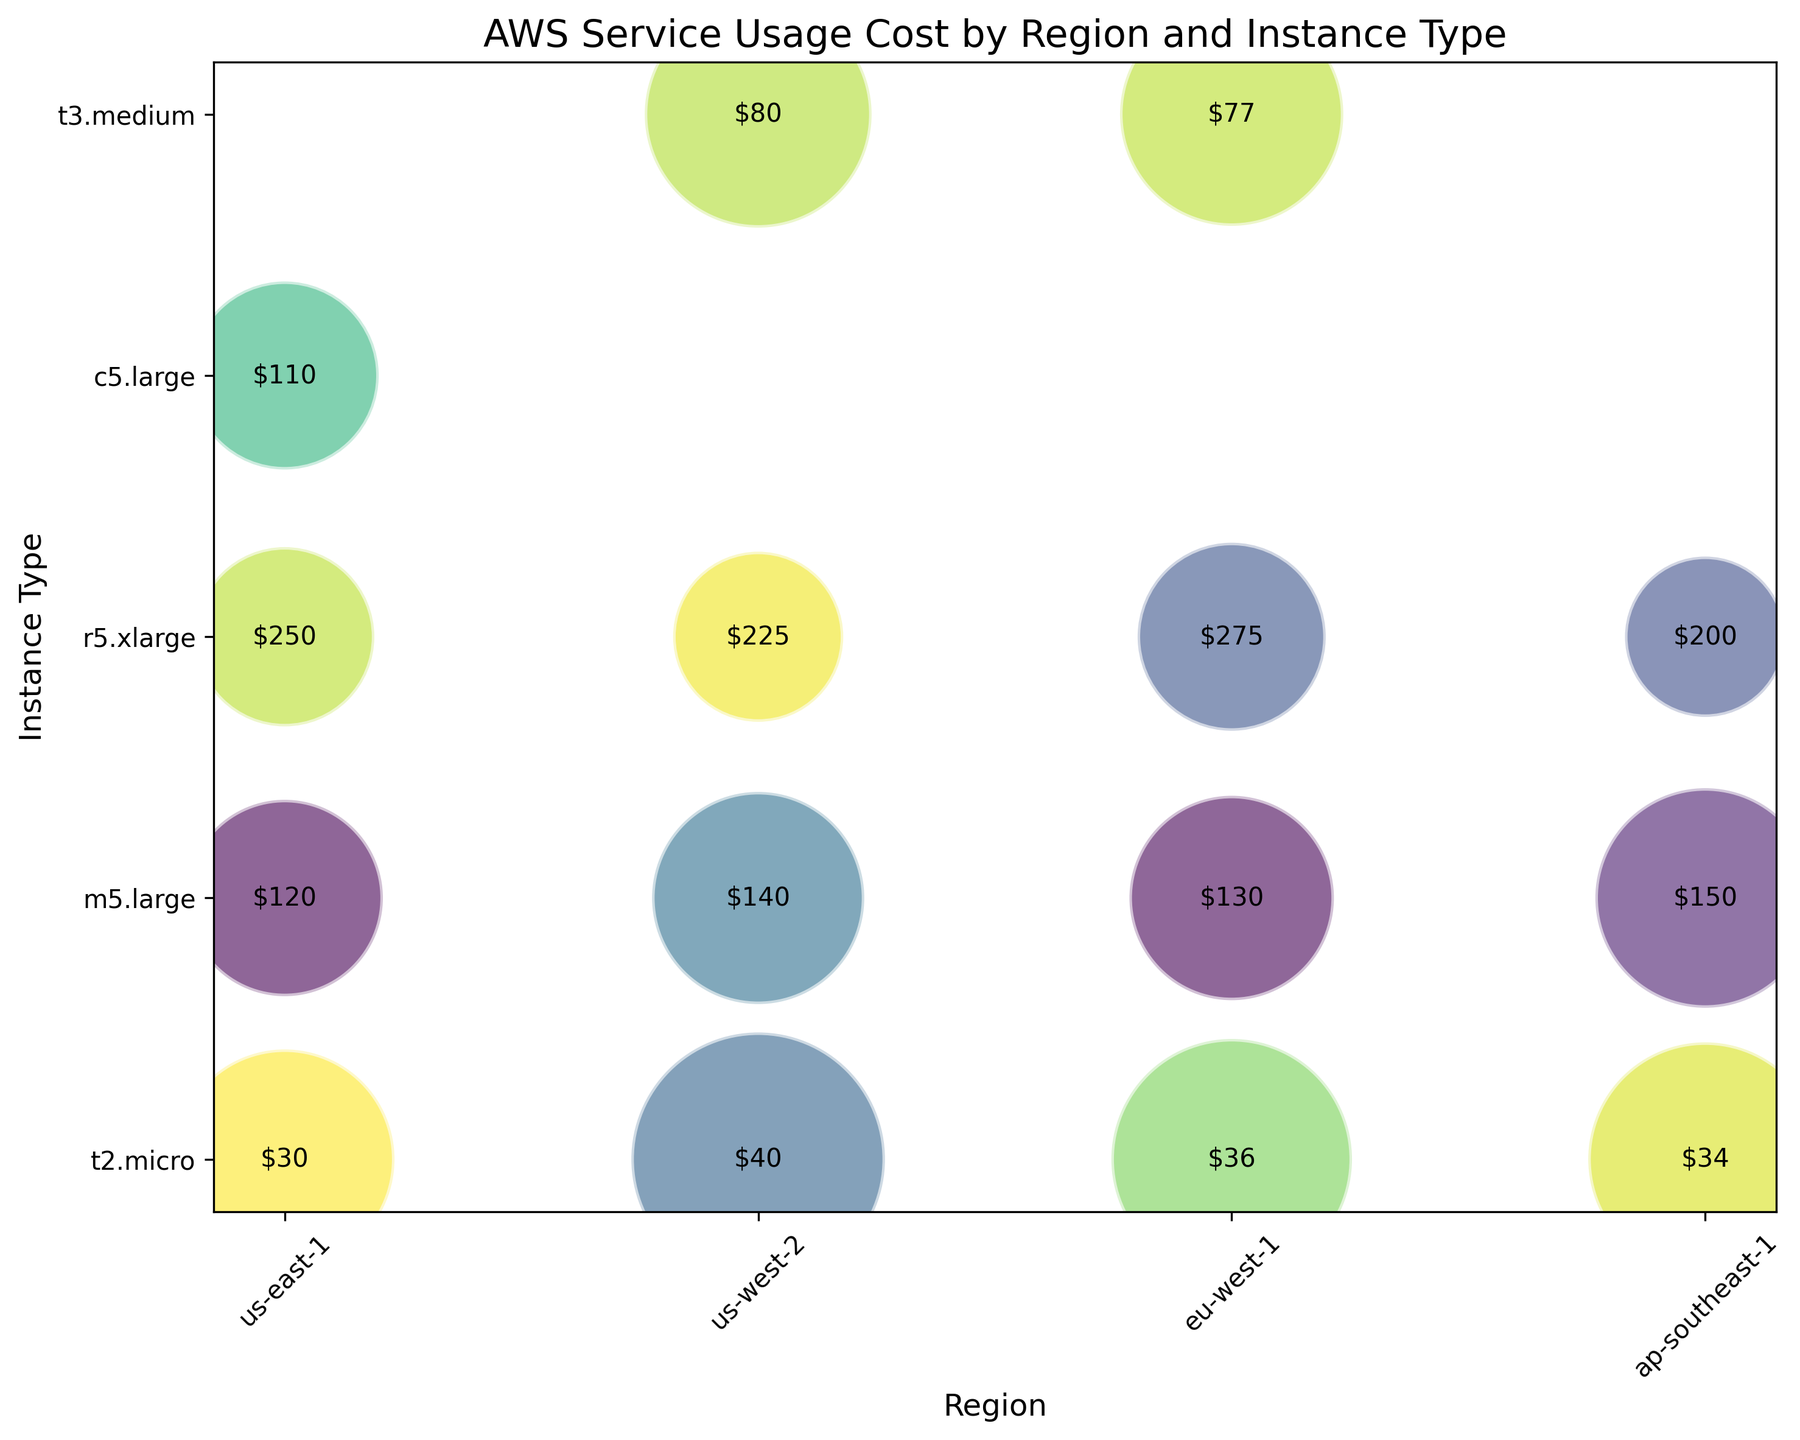Which region has the highest cost for t2.micro instances? Look at the labels within the bubbles corresponding to the t2.micro instance type. Compare the cost values for each region. The highest cost label is in the us-west-2 region with $40.
Answer: us-west-2 Which instance type has the highest cost in eu-west-1? Focus on the bubbles in the eu-west-1 region and compare the cost labels on the bubbles. The highest cost instance type is r5.xlarge with $275.
Answer: r5.xlarge What is the average usage hours for the m5.large instances across all regions? Identify the bubbles for m5.large instances in all regions (us-east-1, us-west-2, eu-west-1, ap-southeast-1). Sum their usage hours (120 + 140 + 130 + 150 = 540). Compute the average by dividing the total usage hours by the number of regions (540 / 4).
Answer: 135 Which region has the most diverse range of instance types? Compare the count of unique instance types in each region: us-east-1 has t2.micro, m5.large, r5.xlarge, c5.large (4 types); us-west-2 has t2.micro, m5.large, r5.xlarge, t3.medium (4 types); eu-west-1 has t2.micro, m5.large, r5.xlarge, t3.medium (4 types); ap-southeast-1 has t2.micro, m5.large, r5.xlarge (3 types). Us-east-1, us-west-2, and eu-west-1 have the most diverse range with 4 instance types each.
Answer: us-east-1, us-west-2, eu-west-1 Is the cost of the m5.large instances higher in ap-southeast-1 or us-west-2? Compare the cost labels on the m5.large bubbles in ap-southeast-1 ($150) and us-west-2 ($140).
Answer: ap-southeast-1 What is the total cost for the r5.xlarge instances across all regions? Identify the r5.xlarge instance type in all regions and sum their costs (us-east-1: $250, us-west-2: $225, eu-west-1: $275, ap-southeast-1: $200). Calculate the total cost (250 + 225 + 275 + 200).
Answer: $950 Which instance type has the largest bubble in the us-east-1 region? Observe the bubbles in the us-east-1 region and compare their sizes. The largest bubble corresponds to the t2.micro instance type.
Answer: t2.micro How does the cost of c5.large in us-east-1 compare to the cost of t3.medium in us-west-2? Compare the cost labels on the c5.large bubble in us-east-1 ($110) and the t3.medium bubble in us-west-2 ($80).
Answer: c5.large has a higher cost What is the difference in usage hours between t2.micro in us-west-2 and t3.medium in eu-west-1? Find the usage hours for t2.micro in us-west-2 (200) and t3.medium in eu-west-1 (155). Calculate the difference (200 - 155).
Answer: 45 Which instance type has the lowest cost in ap-southeast-1? Examine the cost labels on the bubbles in ap-southeast-1 for t2.micro, m5.large, and r5.xlarge. The lowest cost is for t2.micro ($34).
Answer: t2.micro 